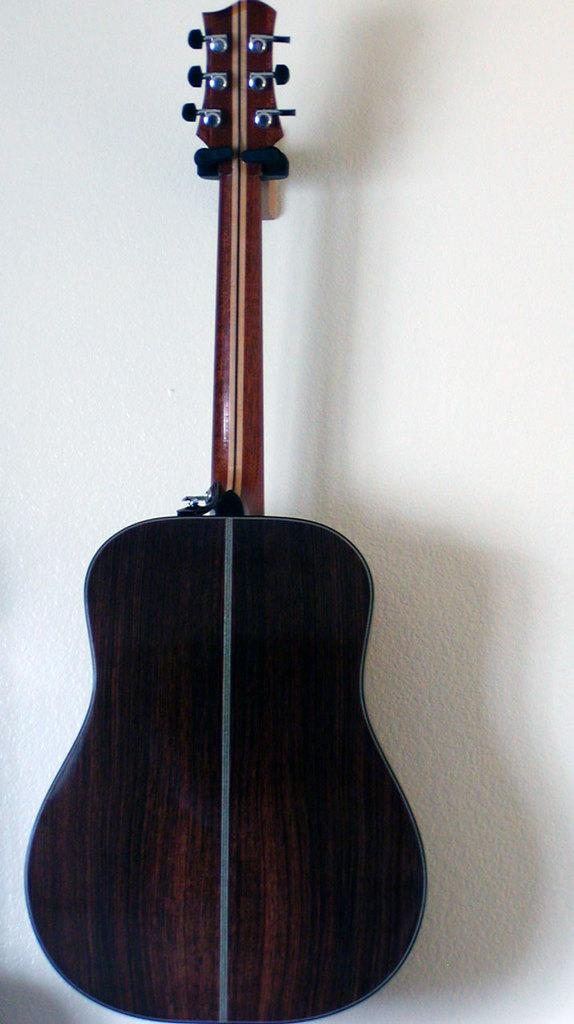What musical instrument is present in the image? There is a guitar in the image. How is the guitar positioned in the image? The headstock of the guitar is attached to the wall. What type of pen is being used to write on the guitar in the image? There is no pen or writing present on the guitar in the image. What magical powers does the guitar possess in the image? The image does not depict any magical powers or abilities of the guitar. 